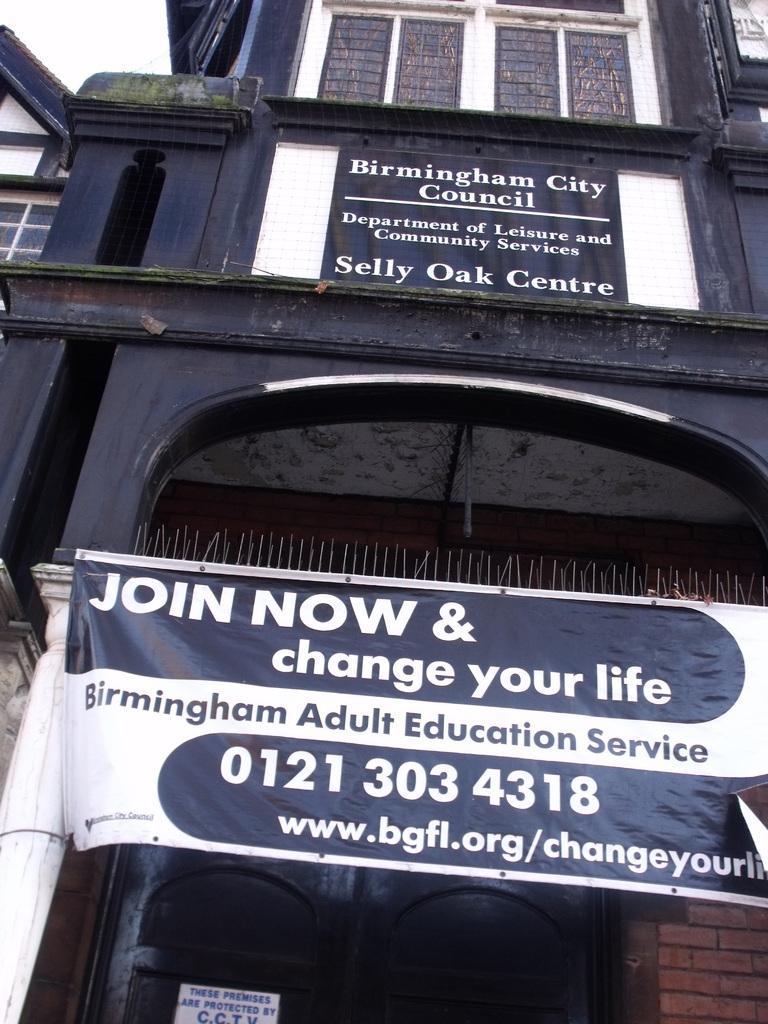In one or two sentences, can you explain what this image depicts? This picture is clicked outside. In the center there is a banner on which the text is printed and we can see a blue color building and we can see the text on the building and we can see the windows and the sky. 